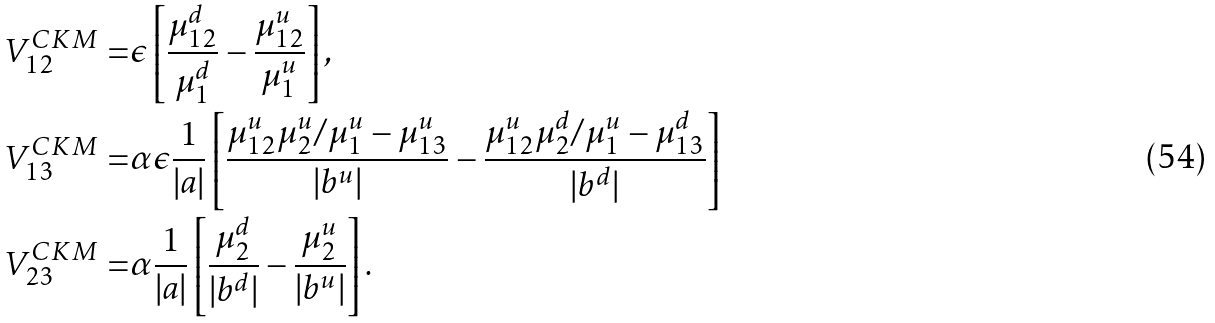<formula> <loc_0><loc_0><loc_500><loc_500>V ^ { C K M } _ { 1 2 } = & \epsilon \left [ \frac { \mu ^ { d } _ { 1 2 } } { \mu ^ { d } _ { 1 } } - \frac { \mu ^ { u } _ { 1 2 } } { \mu ^ { u } _ { 1 } } \right ] , \\ V ^ { C K M } _ { 1 3 } = & \alpha \epsilon \frac { 1 } { | a | } \left [ \frac { \mu ^ { u } _ { 1 2 } \mu ^ { u } _ { 2 } / \mu ^ { u } _ { 1 } - \mu ^ { u } _ { 1 3 } } { | b ^ { u } | } - \frac { \mu ^ { u } _ { 1 2 } \mu ^ { d } _ { 2 } / \mu ^ { u } _ { 1 } - \mu ^ { d } _ { 1 3 } } { | b ^ { d } | } \right ] \\ V ^ { C K M } _ { 2 3 } = & \alpha \frac { 1 } { | a | } \left [ \frac { \mu ^ { d } _ { 2 } } { | b ^ { d } | } - \frac { \mu ^ { u } _ { 2 } } { | b ^ { u } | } \right ] .</formula> 